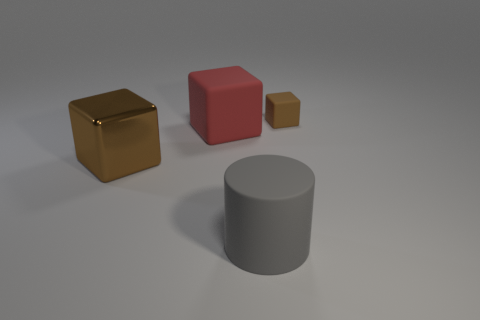How many brown blocks must be subtracted to get 1 brown blocks? 1 Subtract all rubber blocks. How many blocks are left? 1 Subtract all blue spheres. How many brown cubes are left? 2 Add 3 brown metal objects. How many objects exist? 7 Subtract all brown cubes. How many cubes are left? 1 Subtract 2 cubes. How many cubes are left? 1 Subtract all cubes. How many objects are left? 1 Subtract all brown objects. Subtract all gray matte cylinders. How many objects are left? 1 Add 4 rubber objects. How many rubber objects are left? 7 Add 2 cyan balls. How many cyan balls exist? 2 